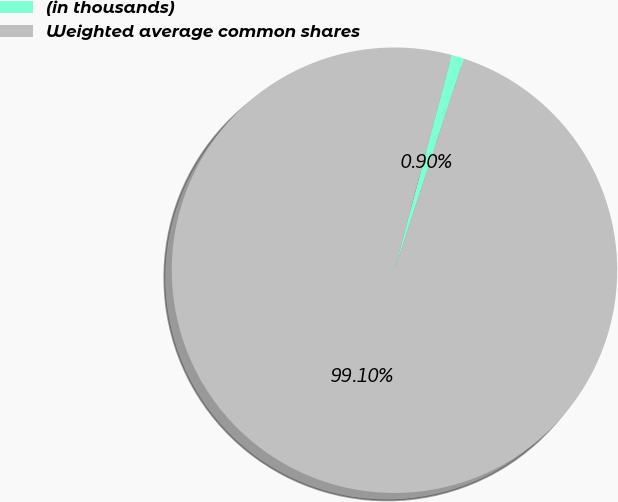Convert chart to OTSL. <chart><loc_0><loc_0><loc_500><loc_500><pie_chart><fcel>(in thousands)<fcel>Weighted average common shares<nl><fcel>0.9%<fcel>99.1%<nl></chart> 